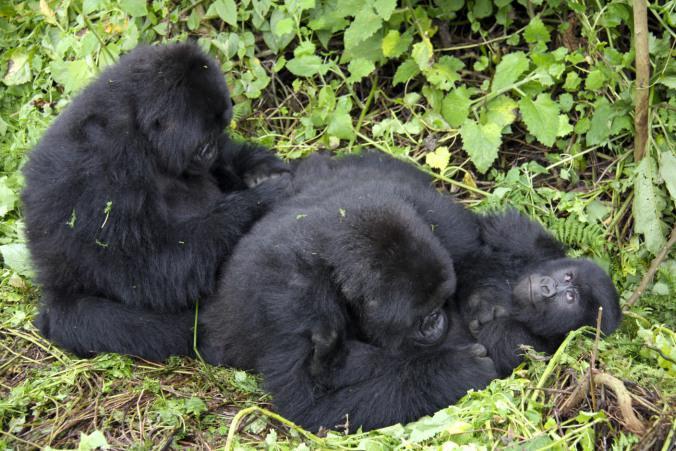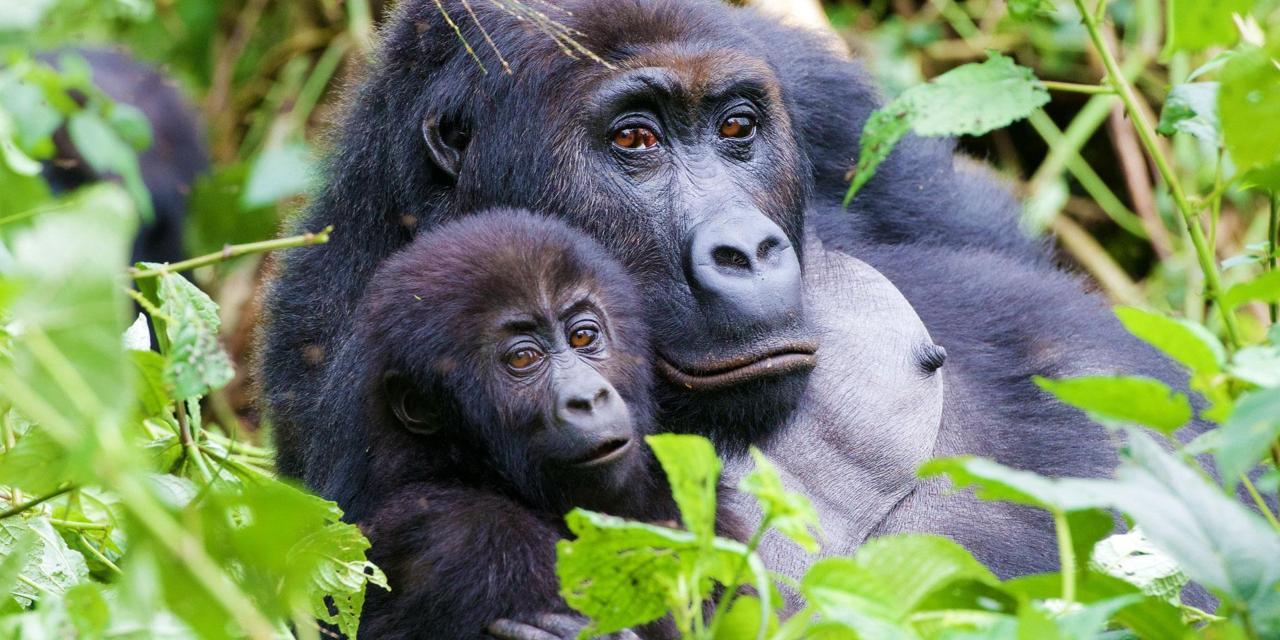The first image is the image on the left, the second image is the image on the right. Assess this claim about the two images: "One of the images depicts a gorilla grooming from behind it.". Correct or not? Answer yes or no. Yes. The first image is the image on the left, the second image is the image on the right. For the images displayed, is the sentence "One image shows one shaggy-haired gorilla grooming the head of a different shaggy haired gorilla, with the curled fingers of one hand facing the camera." factually correct? Answer yes or no. No. 